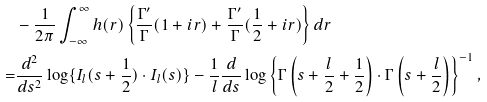Convert formula to latex. <formula><loc_0><loc_0><loc_500><loc_500>& - \frac { 1 } { 2 \pi } \int _ { - \infty } ^ { \infty } h ( r ) \left \{ \frac { \Gamma ^ { \prime } } { \Gamma } ( 1 + i r ) + \frac { \Gamma ^ { \prime } } { \Gamma } ( \frac { 1 } { 2 } + i r ) \right \} d r \\ = & \frac { d ^ { 2 } } { d s ^ { 2 } } \log \{ I _ { l } ( s + \frac { 1 } { 2 } ) \cdot I _ { l } ( s ) \} - \frac { 1 } { l } \frac { d } { d s } \log \left \{ \Gamma \left ( s + \frac { l } { 2 } + \frac { 1 } { 2 } \right ) \cdot \Gamma \left ( s + \frac { l } { 2 } \right ) \right \} ^ { - 1 } ,</formula> 